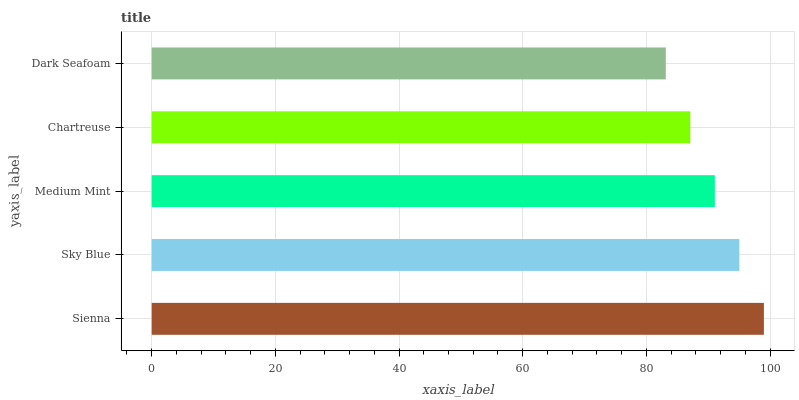Is Dark Seafoam the minimum?
Answer yes or no. Yes. Is Sienna the maximum?
Answer yes or no. Yes. Is Sky Blue the minimum?
Answer yes or no. No. Is Sky Blue the maximum?
Answer yes or no. No. Is Sienna greater than Sky Blue?
Answer yes or no. Yes. Is Sky Blue less than Sienna?
Answer yes or no. Yes. Is Sky Blue greater than Sienna?
Answer yes or no. No. Is Sienna less than Sky Blue?
Answer yes or no. No. Is Medium Mint the high median?
Answer yes or no. Yes. Is Medium Mint the low median?
Answer yes or no. Yes. Is Dark Seafoam the high median?
Answer yes or no. No. Is Dark Seafoam the low median?
Answer yes or no. No. 